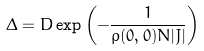<formula> <loc_0><loc_0><loc_500><loc_500>\Delta = D \exp \left ( { - \frac { 1 } { \rho ( 0 , 0 ) N | J | } } \right )</formula> 